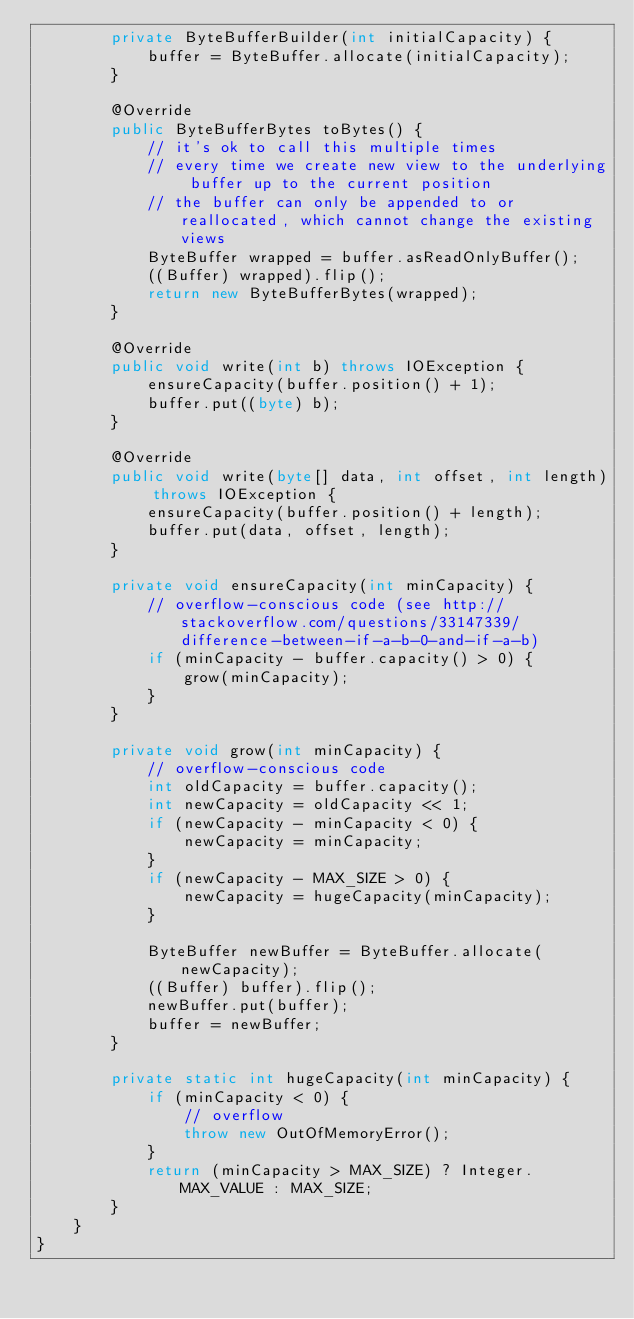<code> <loc_0><loc_0><loc_500><loc_500><_Java_>        private ByteBufferBuilder(int initialCapacity) {
            buffer = ByteBuffer.allocate(initialCapacity);
        }

        @Override
        public ByteBufferBytes toBytes() {
            // it's ok to call this multiple times
            // every time we create new view to the underlying buffer up to the current position
            // the buffer can only be appended to or reallocated, which cannot change the existing views
            ByteBuffer wrapped = buffer.asReadOnlyBuffer();
            ((Buffer) wrapped).flip();
            return new ByteBufferBytes(wrapped);
        }

        @Override
        public void write(int b) throws IOException {
            ensureCapacity(buffer.position() + 1);
            buffer.put((byte) b);
        }

        @Override
        public void write(byte[] data, int offset, int length) throws IOException {
            ensureCapacity(buffer.position() + length);
            buffer.put(data, offset, length);
        }

        private void ensureCapacity(int minCapacity) {
            // overflow-conscious code (see http://stackoverflow.com/questions/33147339/difference-between-if-a-b-0-and-if-a-b)
            if (minCapacity - buffer.capacity() > 0) {
                grow(minCapacity);
            }
        }

        private void grow(int minCapacity) {
            // overflow-conscious code
            int oldCapacity = buffer.capacity();
            int newCapacity = oldCapacity << 1;
            if (newCapacity - minCapacity < 0) {
                newCapacity = minCapacity;
            }
            if (newCapacity - MAX_SIZE > 0) {
                newCapacity = hugeCapacity(minCapacity);
            }

            ByteBuffer newBuffer = ByteBuffer.allocate(newCapacity);
            ((Buffer) buffer).flip();
            newBuffer.put(buffer);
            buffer = newBuffer;
        }

        private static int hugeCapacity(int minCapacity) {
            if (minCapacity < 0) {
                // overflow
                throw new OutOfMemoryError();
            }
            return (minCapacity > MAX_SIZE) ? Integer.MAX_VALUE : MAX_SIZE;
        }
    }
}
</code> 